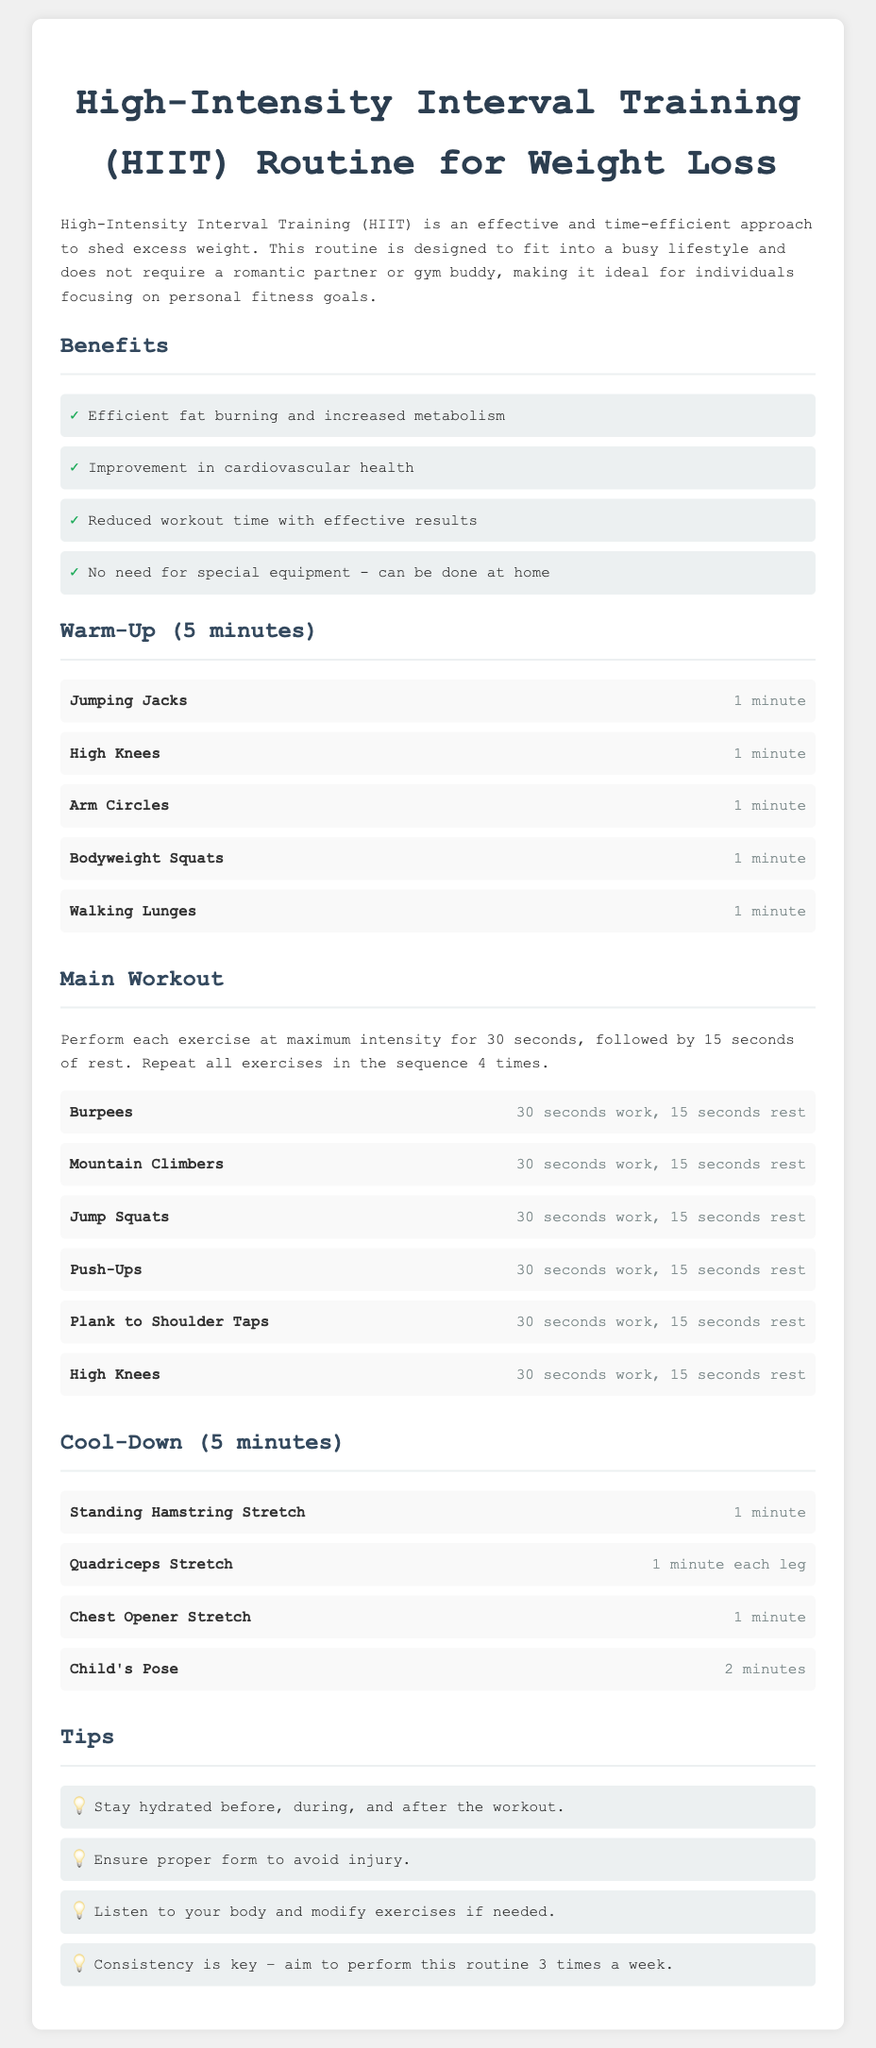What is HIIT? HIIT stands for High-Intensity Interval Training, which is an effective and time-efficient approach to shed excess weight.
Answer: High-Intensity Interval Training How long should the warm-up last? The document specifies that the warm-up should last for 5 minutes.
Answer: 5 minutes What exercise is performed for 30 seconds followed by 15 seconds of rest? The main workout includes several exercises like Burpees, Mountain Climbers, and others that follow this pattern.
Answer: Burpees How many times should the main workout sequence be repeated? The document states that all exercises in the sequence should be repeated 4 times.
Answer: 4 times What is the last exercise listed in the Cool-Down section? The last exercise in the Cool-Down section is Child's Pose.
Answer: Child's Pose What is one benefit of HIIT mentioned in the document? The document highlights several benefits; one mentioned is "efficient fat burning and increased metabolism."
Answer: Efficient fat burning and increased metabolism How often should one aim to perform this routine? The tips section in the document suggests aiming to perform the routine "3 times a week."
Answer: 3 times a week What type of training does this routine focus on? The focus of the routine is High-Intensity Interval Training.
Answer: High-Intensity Interval Training 